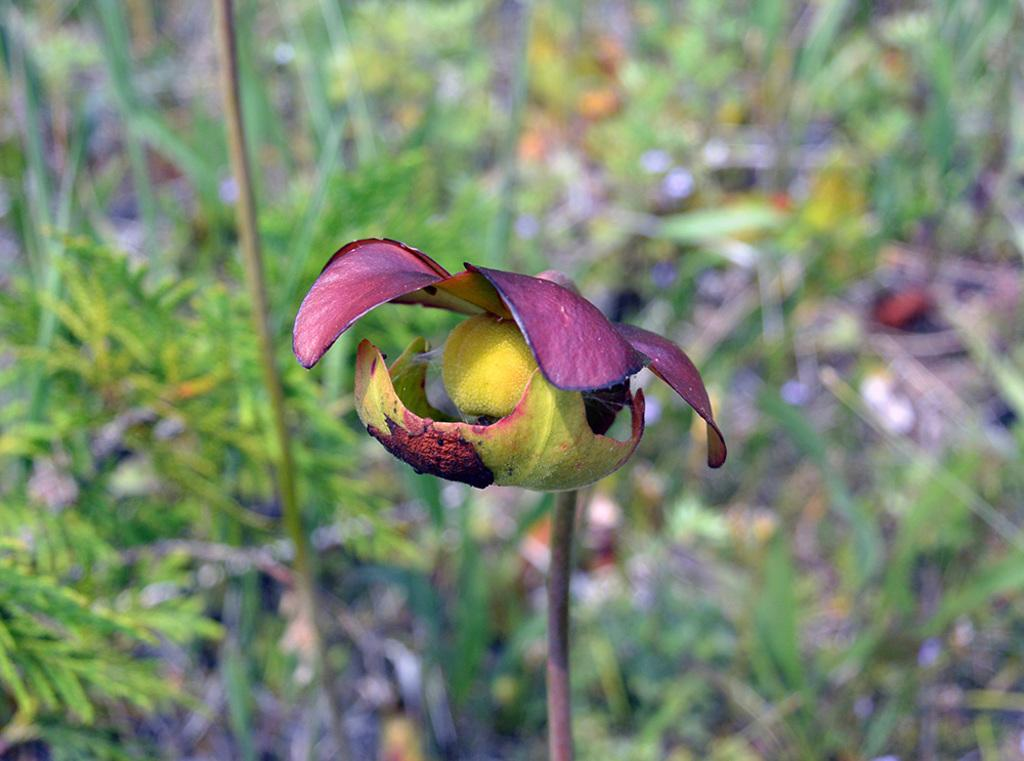What type of plant is present in the image? There is a flower in the image. What type of vegetation is visible in the image besides the flower? There is grass in the image. Can you describe the stem of the plant in the image? The stem of the plant is visible in the image. What type of linen is draped over the bucket in the image? There is no linen or bucket present in the image. 